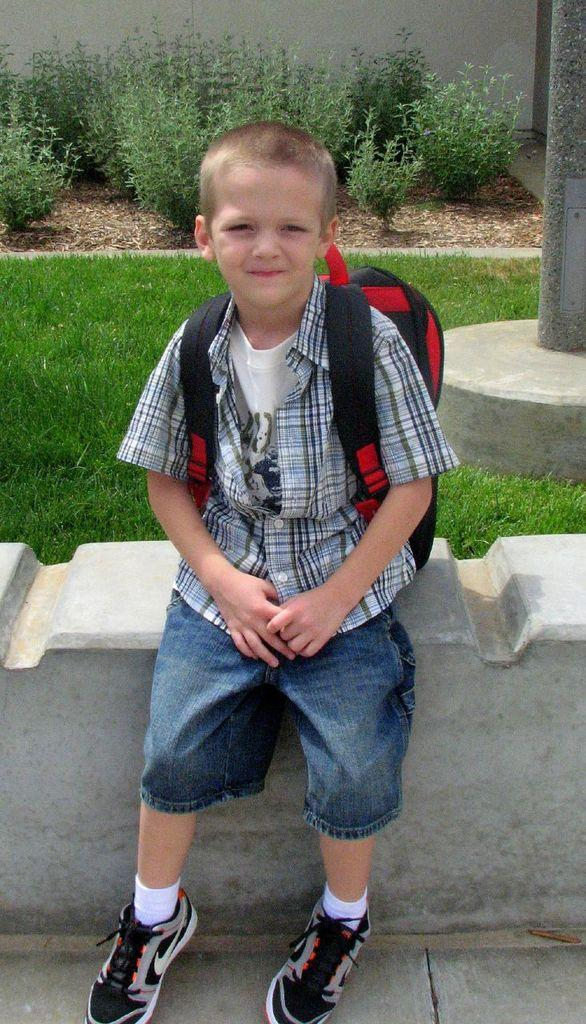What is the main subject of the image? There is a child in the image. What is the child wearing? The child is wearing a shirt, a t-shirt, socks, shoes, and a backpack. What is the child doing in the image? The child is sitting on a wall. What can be seen in the background of the image? There is grass, a pole, plants, and a wall in the background of the image. What type of fear is the child experiencing in the image? There is no indication in the image that the child is experiencing any fear. 